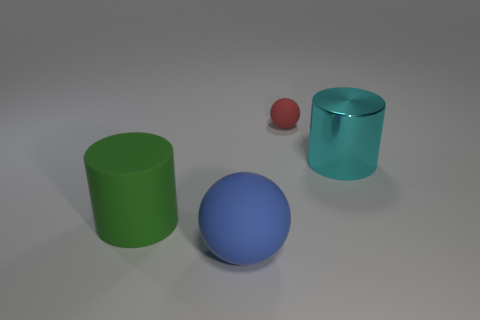What number of cyan objects are large rubber cylinders or big metal cylinders?
Give a very brief answer. 1. The large matte ball has what color?
Offer a very short reply. Blue. Do the cyan metal cylinder and the green cylinder have the same size?
Give a very brief answer. Yes. Is there any other thing that has the same shape as the tiny matte object?
Give a very brief answer. Yes. Are the large cyan thing and the ball that is behind the large blue rubber object made of the same material?
Give a very brief answer. No. There is a rubber ball in front of the metal cylinder; does it have the same color as the small ball?
Offer a terse response. No. What number of rubber things are both in front of the shiny cylinder and behind the big ball?
Your answer should be compact. 1. What number of other things are the same material as the large cyan cylinder?
Provide a short and direct response. 0. Do the big object left of the big sphere and the small red thing have the same material?
Give a very brief answer. Yes. What is the size of the sphere to the left of the ball behind the cylinder behind the big green cylinder?
Keep it short and to the point. Large. 